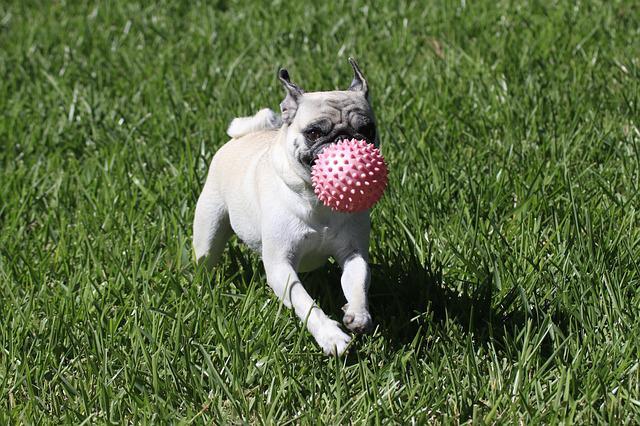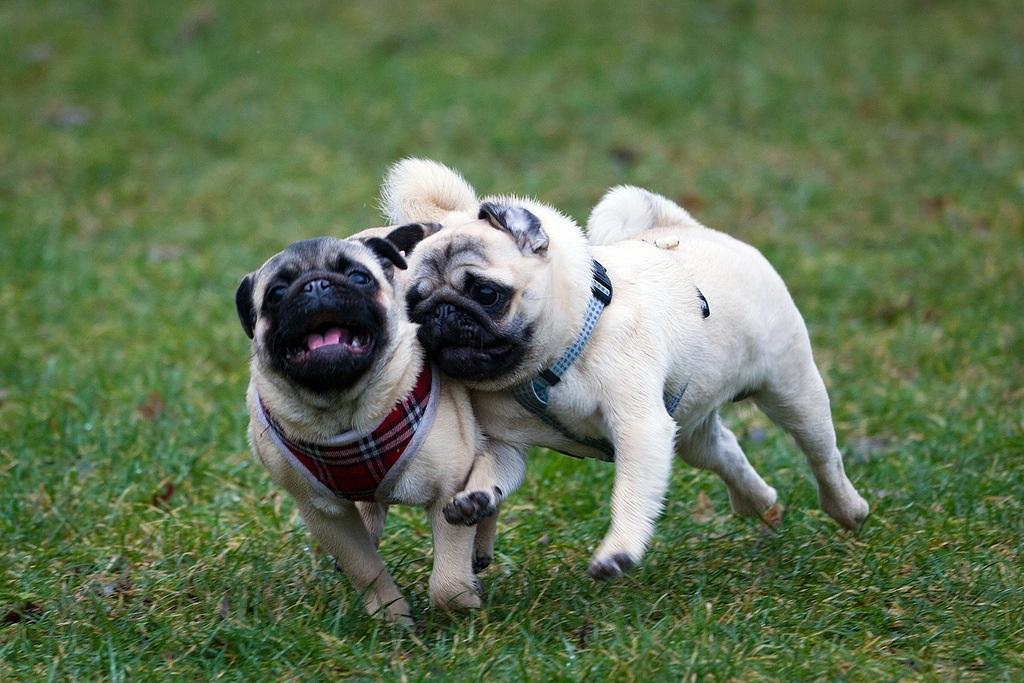The first image is the image on the left, the second image is the image on the right. Examine the images to the left and right. Is the description "There are two dogs." accurate? Answer yes or no. No. The first image is the image on the left, the second image is the image on the right. Evaluate the accuracy of this statement regarding the images: "At least one of the dogs is playing with a ball that has spikes on it.". Is it true? Answer yes or no. Yes. 